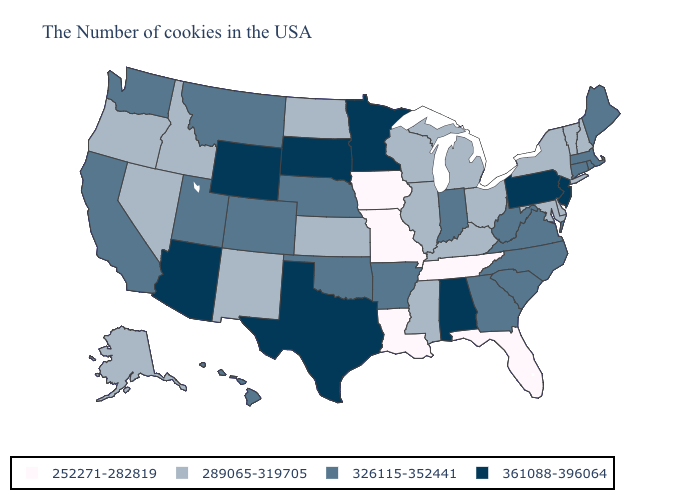What is the value of Colorado?
Short answer required. 326115-352441. Among the states that border North Carolina , which have the lowest value?
Be succinct. Tennessee. Does Maryland have the highest value in the USA?
Concise answer only. No. Which states hav the highest value in the South?
Keep it brief. Alabama, Texas. What is the value of Mississippi?
Write a very short answer. 289065-319705. What is the lowest value in states that border Kansas?
Write a very short answer. 252271-282819. What is the value of Georgia?
Be succinct. 326115-352441. Name the states that have a value in the range 252271-282819?
Short answer required. Florida, Tennessee, Louisiana, Missouri, Iowa. Name the states that have a value in the range 252271-282819?
Quick response, please. Florida, Tennessee, Louisiana, Missouri, Iowa. Which states have the lowest value in the West?
Concise answer only. New Mexico, Idaho, Nevada, Oregon, Alaska. Which states have the highest value in the USA?
Be succinct. New Jersey, Pennsylvania, Alabama, Minnesota, Texas, South Dakota, Wyoming, Arizona. Does the first symbol in the legend represent the smallest category?
Keep it brief. Yes. Which states hav the highest value in the Northeast?
Keep it brief. New Jersey, Pennsylvania. Does West Virginia have the highest value in the South?
Short answer required. No. What is the value of Arizona?
Concise answer only. 361088-396064. 